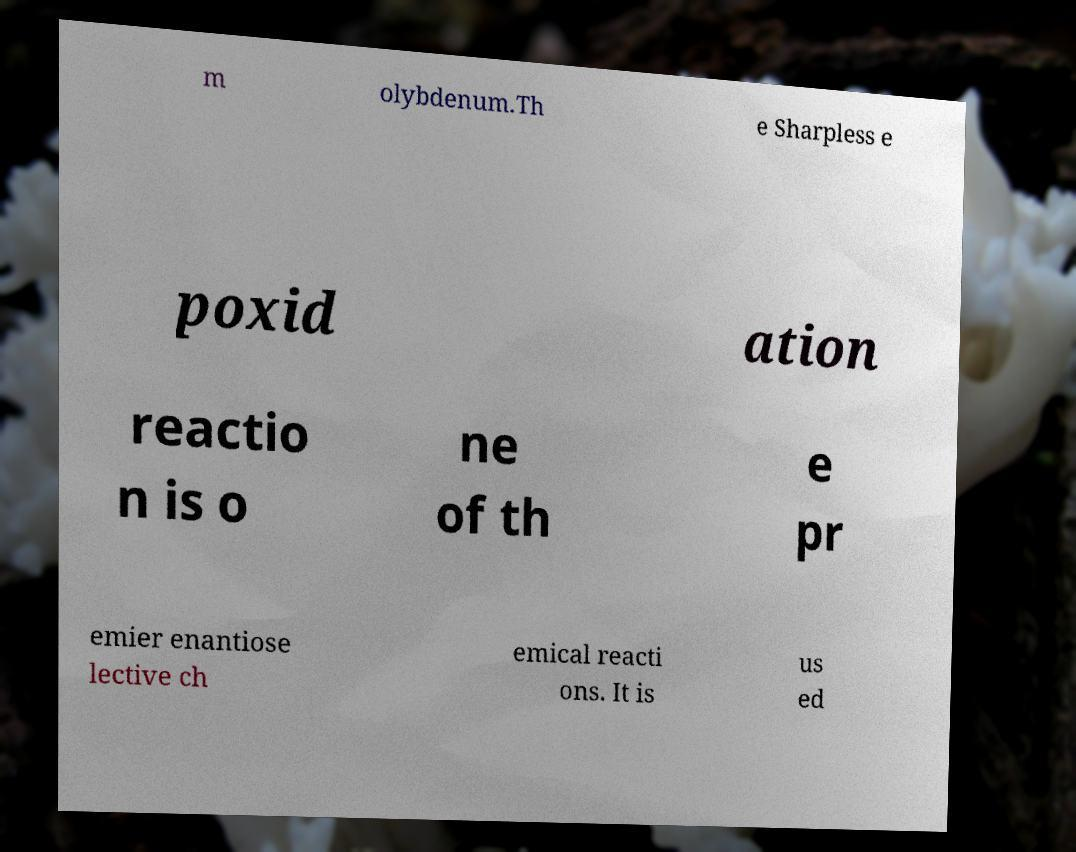I need the written content from this picture converted into text. Can you do that? m olybdenum.Th e Sharpless e poxid ation reactio n is o ne of th e pr emier enantiose lective ch emical reacti ons. It is us ed 